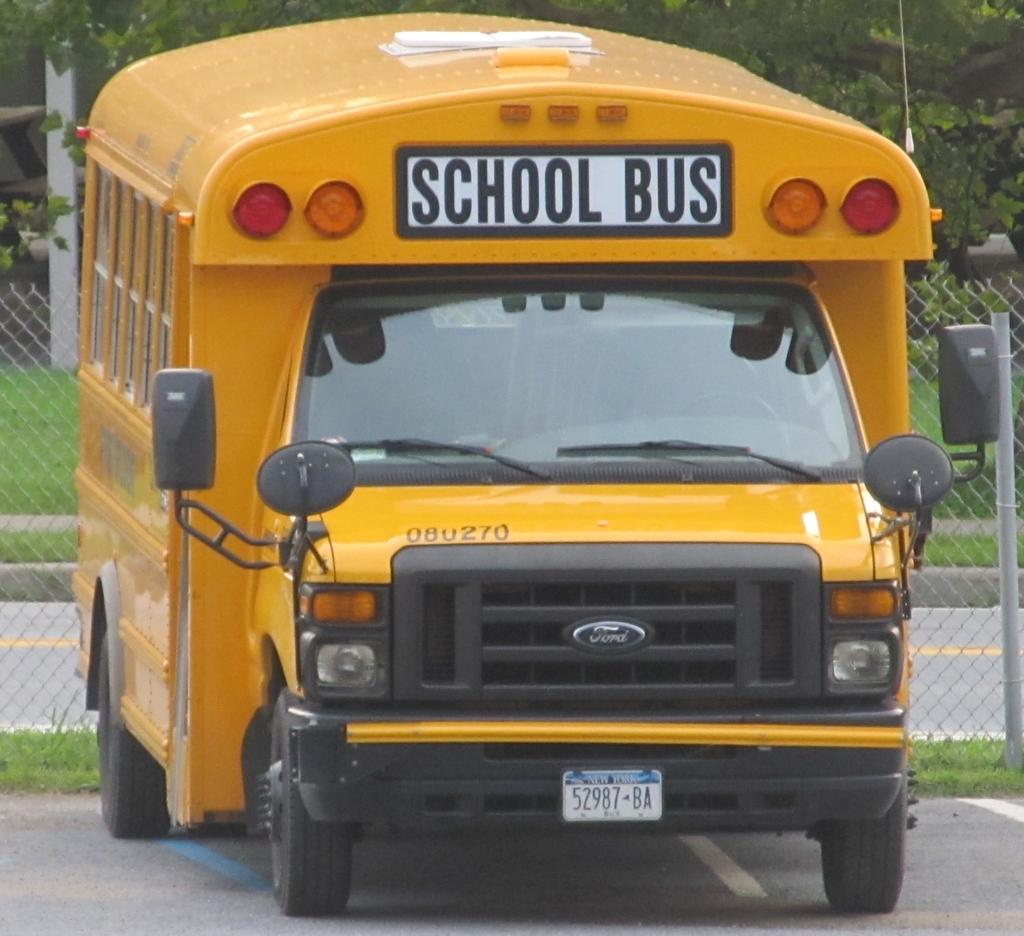Provide a one-sentence caption for the provided image. A large yellow school bus manufactured by Ford. 